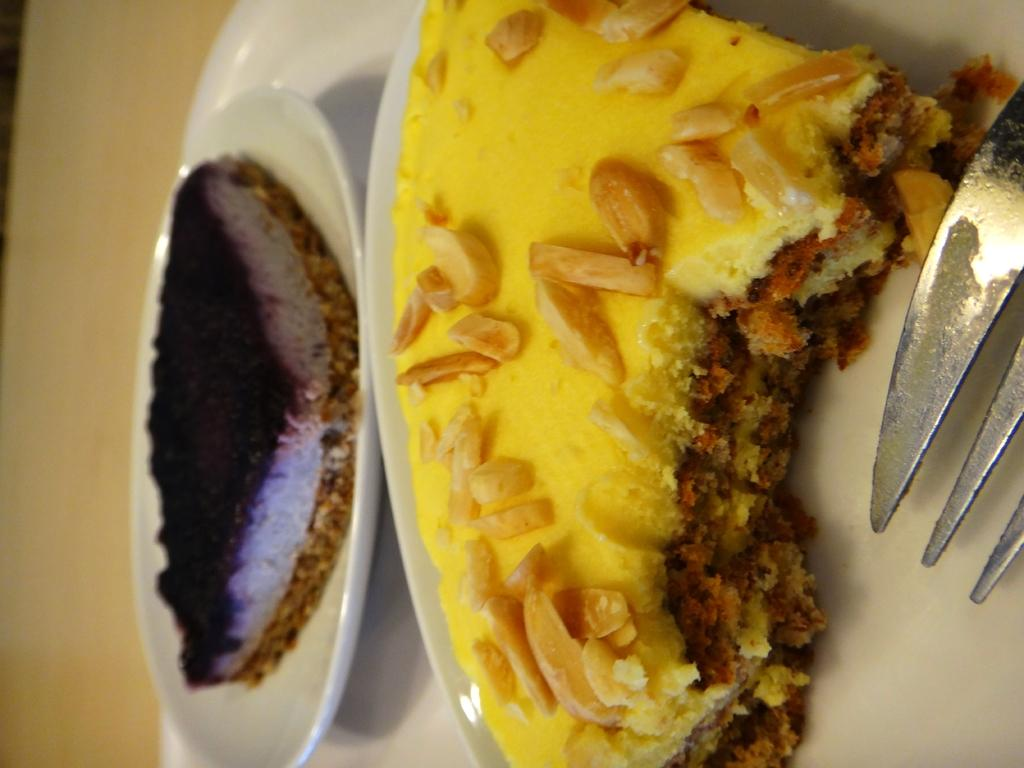What is the main subject of the image? There is a food item on a plate in the image. What utensil is placed near the food item? There is a fork beside the food item. Can you describe another food item visible in the image? There is another food item on a white-colored plate in the image. What type of doll is sitting on the plate and acting in the image? There is no doll present in the image, and therefore no doll can be seen acting or sitting on the plate. 